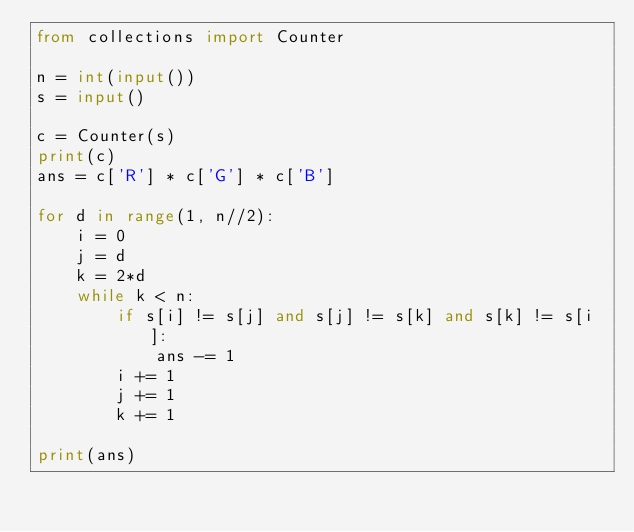Convert code to text. <code><loc_0><loc_0><loc_500><loc_500><_Python_>from collections import Counter

n = int(input())
s = input()

c = Counter(s)
print(c)
ans = c['R'] * c['G'] * c['B']

for d in range(1, n//2):
    i = 0
    j = d
    k = 2*d
    while k < n:
        if s[i] != s[j] and s[j] != s[k] and s[k] != s[i]:
            ans -= 1
        i += 1
        j += 1
        k += 1

print(ans)
</code> 